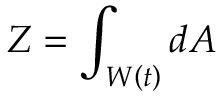Convert formula to latex. <formula><loc_0><loc_0><loc_500><loc_500>Z = \int _ { W \left ( t \right ) } d A</formula> 